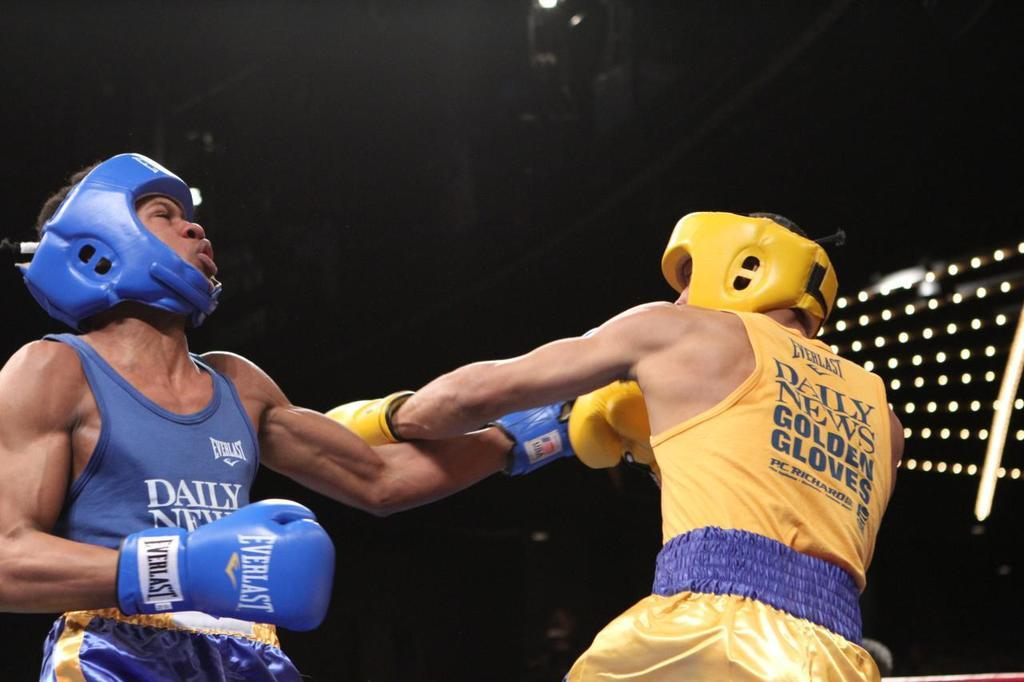<image>
Create a compact narrative representing the image presented. two boxers boxing in "everlast" shirts with "Daily News Golden Gloves" printed on them 